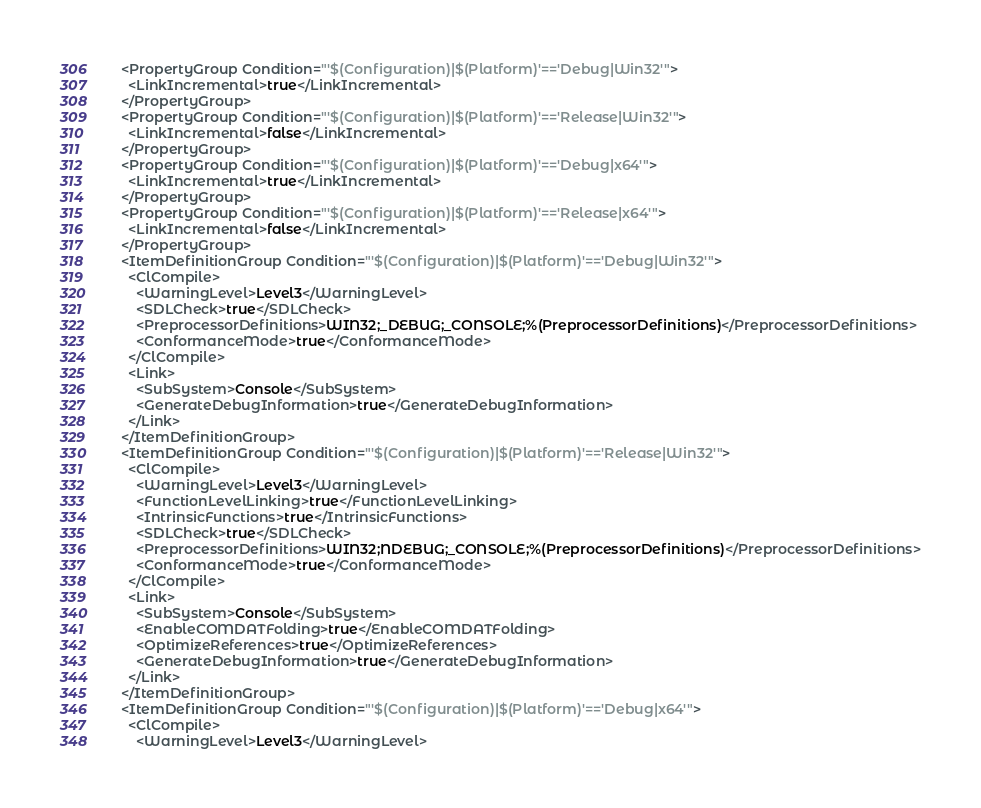Convert code to text. <code><loc_0><loc_0><loc_500><loc_500><_XML_>  <PropertyGroup Condition="'$(Configuration)|$(Platform)'=='Debug|Win32'">
    <LinkIncremental>true</LinkIncremental>
  </PropertyGroup>
  <PropertyGroup Condition="'$(Configuration)|$(Platform)'=='Release|Win32'">
    <LinkIncremental>false</LinkIncremental>
  </PropertyGroup>
  <PropertyGroup Condition="'$(Configuration)|$(Platform)'=='Debug|x64'">
    <LinkIncremental>true</LinkIncremental>
  </PropertyGroup>
  <PropertyGroup Condition="'$(Configuration)|$(Platform)'=='Release|x64'">
    <LinkIncremental>false</LinkIncremental>
  </PropertyGroup>
  <ItemDefinitionGroup Condition="'$(Configuration)|$(Platform)'=='Debug|Win32'">
    <ClCompile>
      <WarningLevel>Level3</WarningLevel>
      <SDLCheck>true</SDLCheck>
      <PreprocessorDefinitions>WIN32;_DEBUG;_CONSOLE;%(PreprocessorDefinitions)</PreprocessorDefinitions>
      <ConformanceMode>true</ConformanceMode>
    </ClCompile>
    <Link>
      <SubSystem>Console</SubSystem>
      <GenerateDebugInformation>true</GenerateDebugInformation>
    </Link>
  </ItemDefinitionGroup>
  <ItemDefinitionGroup Condition="'$(Configuration)|$(Platform)'=='Release|Win32'">
    <ClCompile>
      <WarningLevel>Level3</WarningLevel>
      <FunctionLevelLinking>true</FunctionLevelLinking>
      <IntrinsicFunctions>true</IntrinsicFunctions>
      <SDLCheck>true</SDLCheck>
      <PreprocessorDefinitions>WIN32;NDEBUG;_CONSOLE;%(PreprocessorDefinitions)</PreprocessorDefinitions>
      <ConformanceMode>true</ConformanceMode>
    </ClCompile>
    <Link>
      <SubSystem>Console</SubSystem>
      <EnableCOMDATFolding>true</EnableCOMDATFolding>
      <OptimizeReferences>true</OptimizeReferences>
      <GenerateDebugInformation>true</GenerateDebugInformation>
    </Link>
  </ItemDefinitionGroup>
  <ItemDefinitionGroup Condition="'$(Configuration)|$(Platform)'=='Debug|x64'">
    <ClCompile>
      <WarningLevel>Level3</WarningLevel></code> 